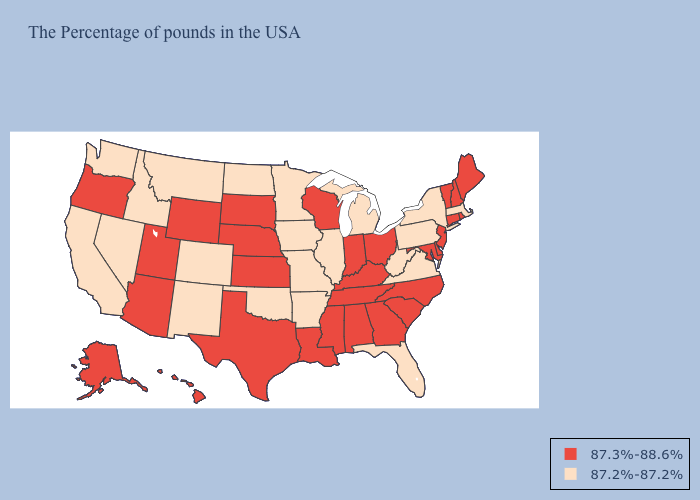What is the lowest value in states that border Louisiana?
Keep it brief. 87.2%-87.2%. Does Maryland have a higher value than West Virginia?
Write a very short answer. Yes. Name the states that have a value in the range 87.3%-88.6%?
Write a very short answer. Maine, Rhode Island, New Hampshire, Vermont, Connecticut, New Jersey, Delaware, Maryland, North Carolina, South Carolina, Ohio, Georgia, Kentucky, Indiana, Alabama, Tennessee, Wisconsin, Mississippi, Louisiana, Kansas, Nebraska, Texas, South Dakota, Wyoming, Utah, Arizona, Oregon, Alaska, Hawaii. What is the lowest value in states that border Wisconsin?
Write a very short answer. 87.2%-87.2%. Name the states that have a value in the range 87.3%-88.6%?
Give a very brief answer. Maine, Rhode Island, New Hampshire, Vermont, Connecticut, New Jersey, Delaware, Maryland, North Carolina, South Carolina, Ohio, Georgia, Kentucky, Indiana, Alabama, Tennessee, Wisconsin, Mississippi, Louisiana, Kansas, Nebraska, Texas, South Dakota, Wyoming, Utah, Arizona, Oregon, Alaska, Hawaii. Does South Dakota have the lowest value in the USA?
Short answer required. No. Does Nevada have a lower value than Michigan?
Write a very short answer. No. Name the states that have a value in the range 87.3%-88.6%?
Be succinct. Maine, Rhode Island, New Hampshire, Vermont, Connecticut, New Jersey, Delaware, Maryland, North Carolina, South Carolina, Ohio, Georgia, Kentucky, Indiana, Alabama, Tennessee, Wisconsin, Mississippi, Louisiana, Kansas, Nebraska, Texas, South Dakota, Wyoming, Utah, Arizona, Oregon, Alaska, Hawaii. Name the states that have a value in the range 87.3%-88.6%?
Answer briefly. Maine, Rhode Island, New Hampshire, Vermont, Connecticut, New Jersey, Delaware, Maryland, North Carolina, South Carolina, Ohio, Georgia, Kentucky, Indiana, Alabama, Tennessee, Wisconsin, Mississippi, Louisiana, Kansas, Nebraska, Texas, South Dakota, Wyoming, Utah, Arizona, Oregon, Alaska, Hawaii. Name the states that have a value in the range 87.2%-87.2%?
Write a very short answer. Massachusetts, New York, Pennsylvania, Virginia, West Virginia, Florida, Michigan, Illinois, Missouri, Arkansas, Minnesota, Iowa, Oklahoma, North Dakota, Colorado, New Mexico, Montana, Idaho, Nevada, California, Washington. Among the states that border New Jersey , which have the lowest value?
Quick response, please. New York, Pennsylvania. Which states hav the highest value in the MidWest?
Quick response, please. Ohio, Indiana, Wisconsin, Kansas, Nebraska, South Dakota. What is the value of Alabama?
Write a very short answer. 87.3%-88.6%. What is the lowest value in the Northeast?
Keep it brief. 87.2%-87.2%. Name the states that have a value in the range 87.2%-87.2%?
Give a very brief answer. Massachusetts, New York, Pennsylvania, Virginia, West Virginia, Florida, Michigan, Illinois, Missouri, Arkansas, Minnesota, Iowa, Oklahoma, North Dakota, Colorado, New Mexico, Montana, Idaho, Nevada, California, Washington. 